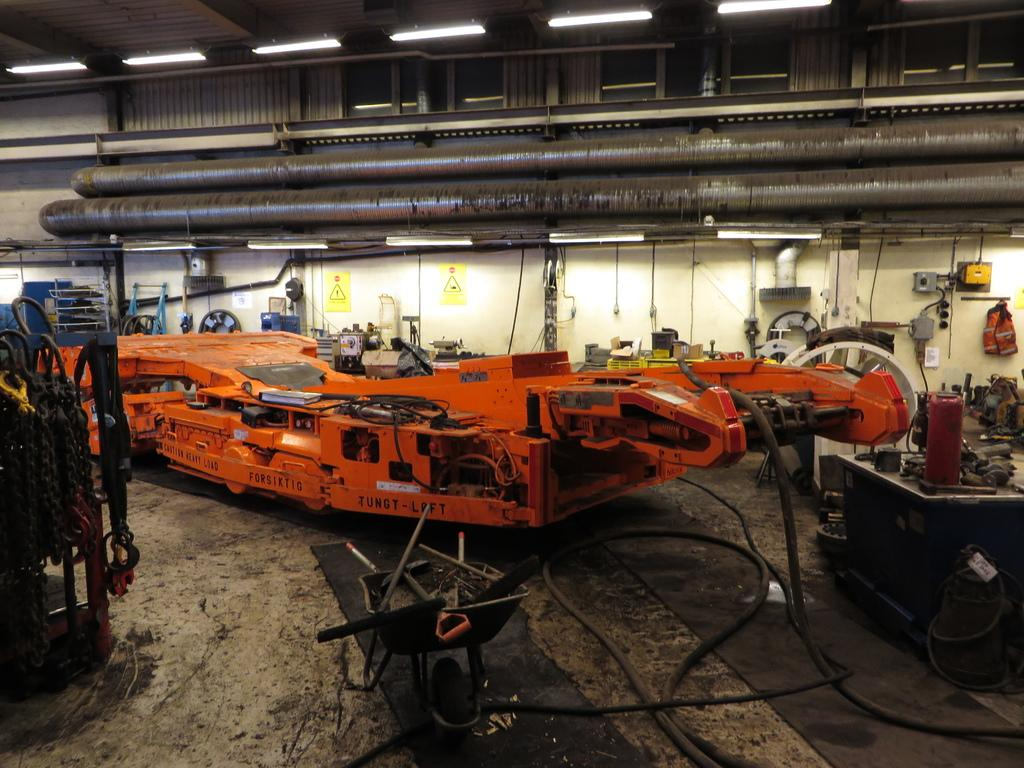What type of equipment can be seen in the image? There are machines in the image. What kind of setting does the image depict? The image appears to depict a manufacturing unit. What is the surface on which the machines are placed? There is a floor at the bottom of the image. What is visible at the top of the image? There is a roof with lights at the top of the image. Who is the friend that is helping with the manufacturing process in the image? There is no friend present in the image; it depicts machines and a manufacturing setting. 